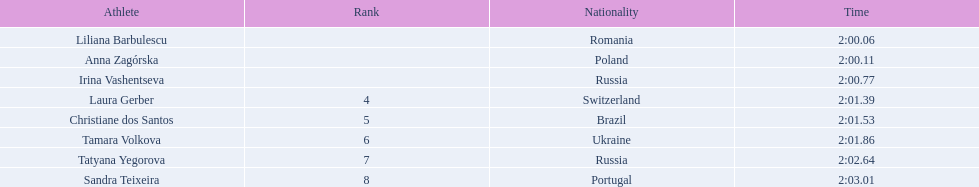Who are all of the athletes? Liliana Barbulescu, Anna Zagórska, Irina Vashentseva, Laura Gerber, Christiane dos Santos, Tamara Volkova, Tatyana Yegorova, Sandra Teixeira. What were their times in the heat? 2:00.06, 2:00.11, 2:00.77, 2:01.39, 2:01.53, 2:01.86, 2:02.64, 2:03.01. Of these, which is the top time? 2:00.06. Which athlete had this time? Liliana Barbulescu. 